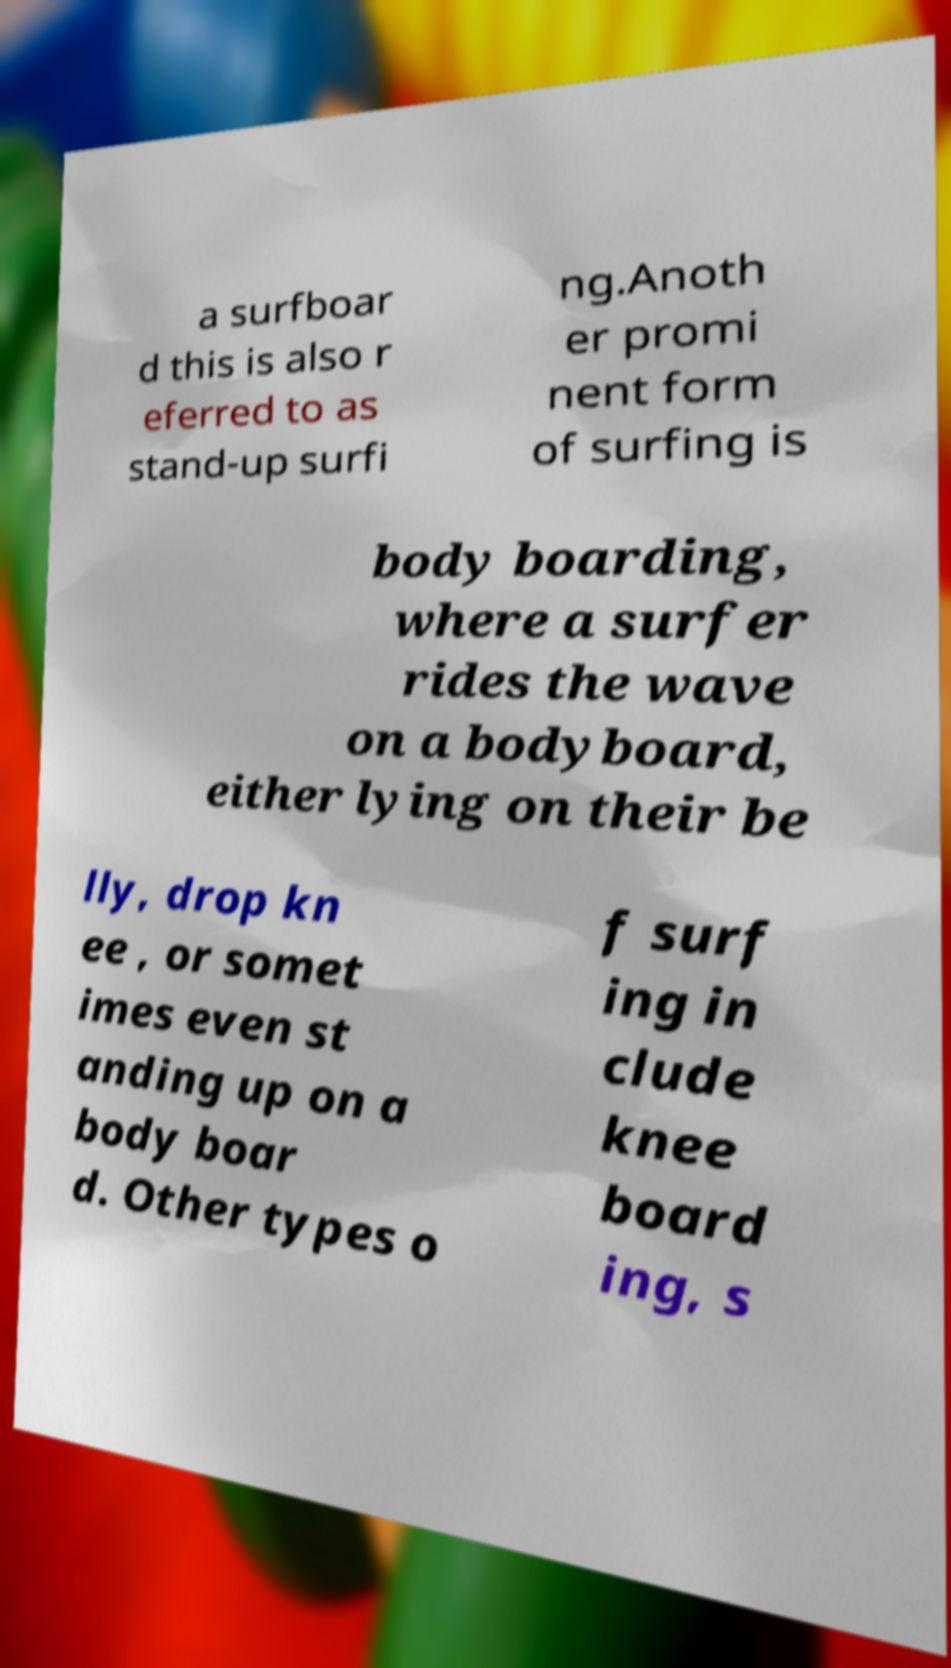Can you accurately transcribe the text from the provided image for me? a surfboar d this is also r eferred to as stand-up surfi ng.Anoth er promi nent form of surfing is body boarding, where a surfer rides the wave on a bodyboard, either lying on their be lly, drop kn ee , or somet imes even st anding up on a body boar d. Other types o f surf ing in clude knee board ing, s 